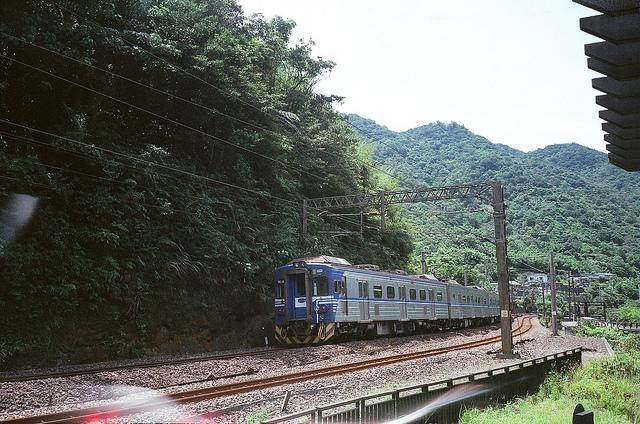How many tracks can be seen?
Give a very brief answer. 2. How many people are on the pic?
Give a very brief answer. 0. 